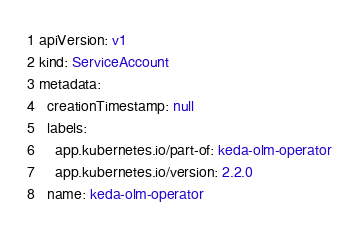Convert code to text. <code><loc_0><loc_0><loc_500><loc_500><_YAML_>apiVersion: v1
kind: ServiceAccount
metadata:
  creationTimestamp: null
  labels:
    app.kubernetes.io/part-of: keda-olm-operator
    app.kubernetes.io/version: 2.2.0
  name: keda-olm-operator
</code> 